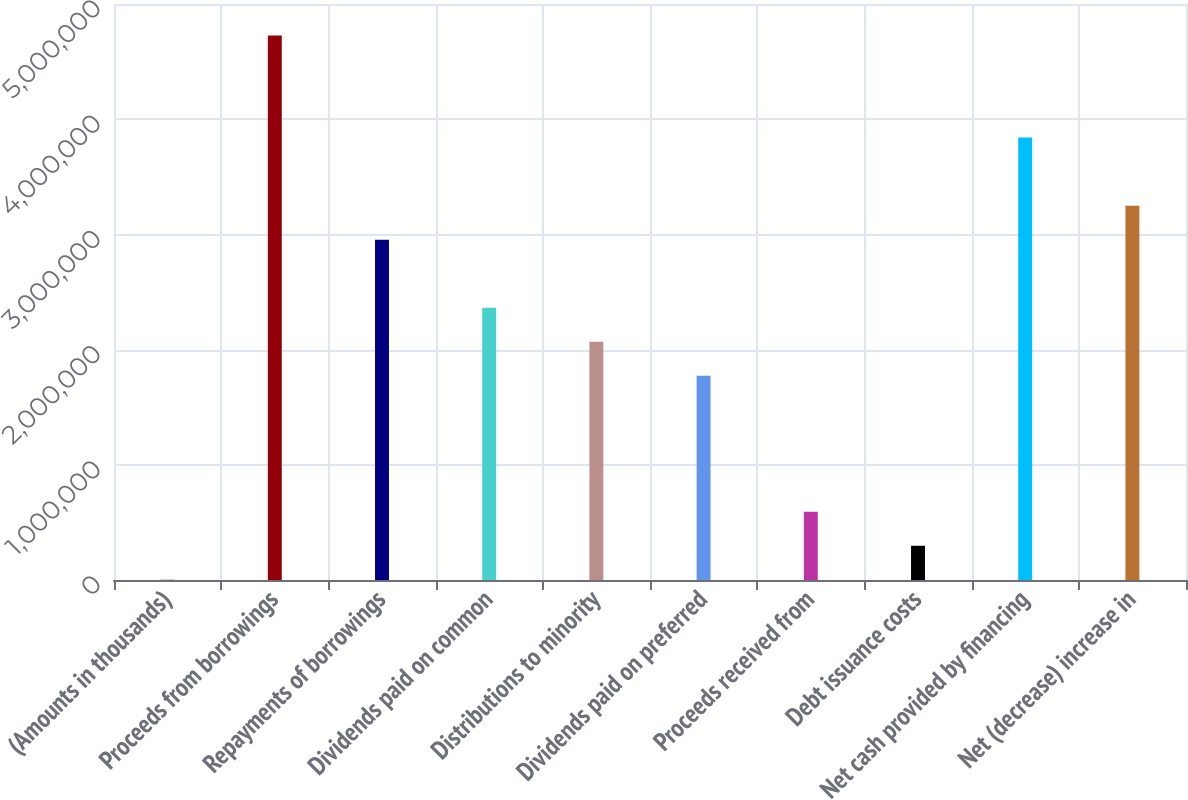<chart> <loc_0><loc_0><loc_500><loc_500><bar_chart><fcel>(Amounts in thousands)<fcel>Proceeds from borrowings<fcel>Repayments of borrowings<fcel>Dividends paid on common<fcel>Distributions to minority<fcel>Dividends paid on preferred<fcel>Proceeds received from<fcel>Debt issuance costs<fcel>Net cash provided by financing<fcel>Net (decrease) increase in<nl><fcel>2007<fcel>4.72599e+06<fcel>2.9545e+06<fcel>2.364e+06<fcel>2.06875e+06<fcel>1.7735e+06<fcel>592505<fcel>297256<fcel>3.84024e+06<fcel>3.24975e+06<nl></chart> 